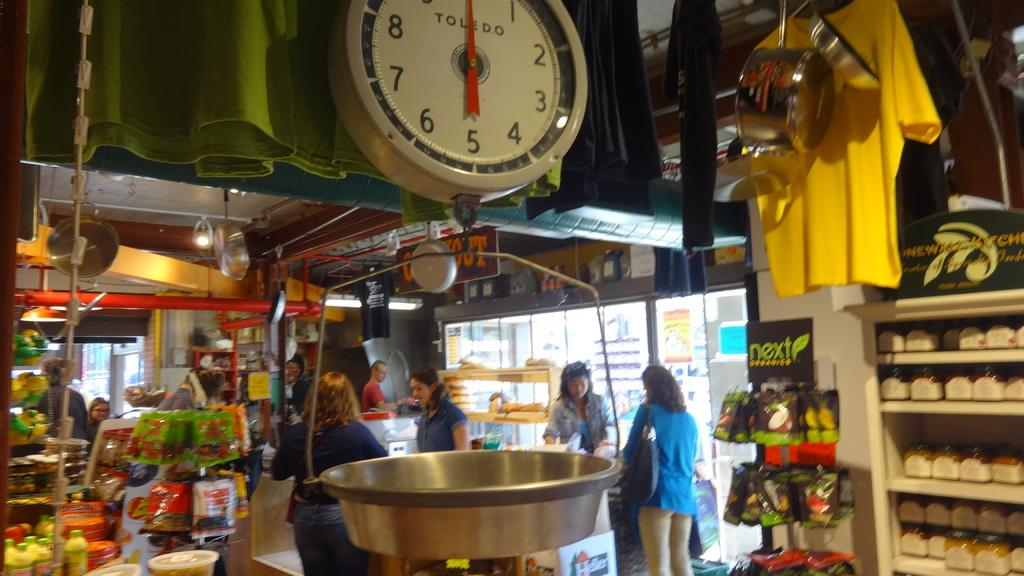What type of establishment is depicted in the image? There is a grocery store in the image. What can be found inside the grocery store? There are grocery items in the store. What tool is available for measuring the weight of items in the store? There is a weighing machine in the store. Are there any customers or employees present in the image? Yes, there are people in the store. What type of liquid can be seen flowing from the ceiling in the image? There is no liquid flowing from the ceiling in the image. Can you see a ticket dispenser near the entrance of the store in the image? There is no ticket dispenser mentioned in the provided facts, so it cannot be confirmed from the image. --- Facts: 1. There is a car in the image. 2. The car is parked on the street. 3. There are streetlights in the image. 4. The street is paved. 5. There are buildings in the background. Absurd Topics: parrot, sand, ocean Conversation: What type of vehicle is in the image? There is a car in the image. Where is the car located? The car is parked on the street. What type of lighting is present in the image? There are streetlights in the image. What is the surface of the street made of? The street is paved. What can be seen in the background of the image? There are buildings in the background. Reasoning: Let's think step by step in order to produce the conversation. We start by identifying the main subject of the image, which is the car. Then, we describe the location of the car, the presence of streetlights, the surface of the street, and the background. Each question is designed to elicit a specific detail about the image that is known from the provided facts. Absurd Question/Answer: Can you see a parrot perched on the car's roof in the image? There is no mention of a parrot in the provided facts, so it cannot be confirmed from the image. Is the car parked near a sandy beach in the image? There is no mention of a beach or sand in the provided facts, so it cannot be confirmed from the image. 